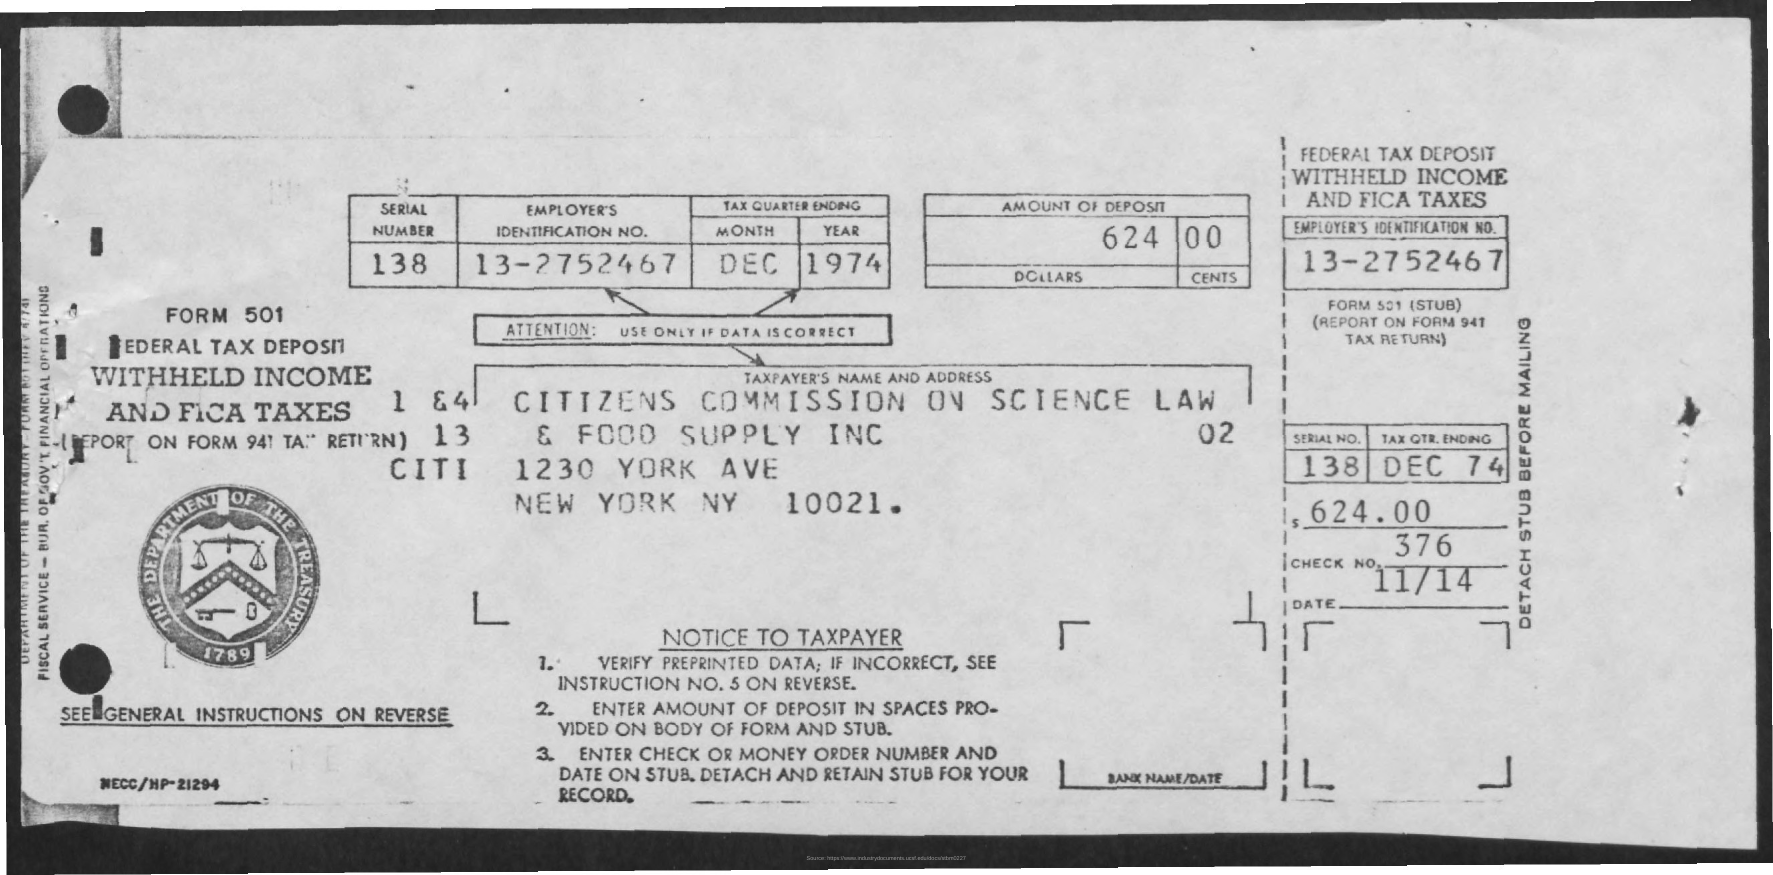What is the Year? The year indicated on the tax form image is 1974, which can be clearly seen in the top right section of the form, within the box labeled 'TAX QUARTER ENDING' under 'YEAR.' 